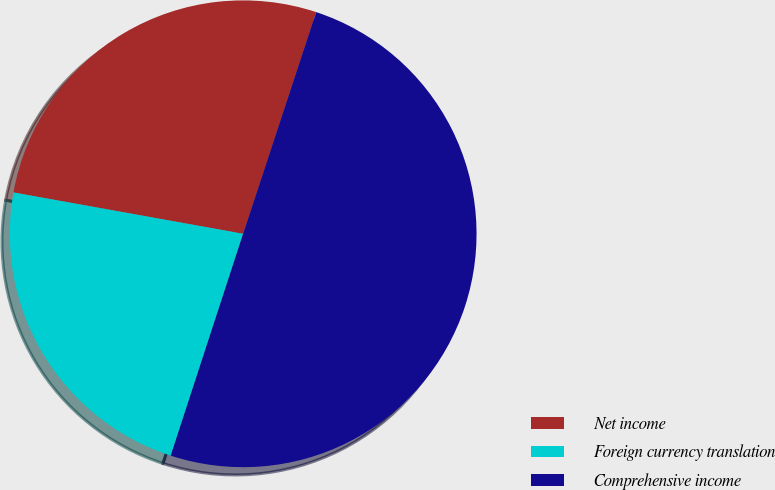<chart> <loc_0><loc_0><loc_500><loc_500><pie_chart><fcel>Net income<fcel>Foreign currency translation<fcel>Comprehensive income<nl><fcel>27.23%<fcel>22.81%<fcel>49.95%<nl></chart> 